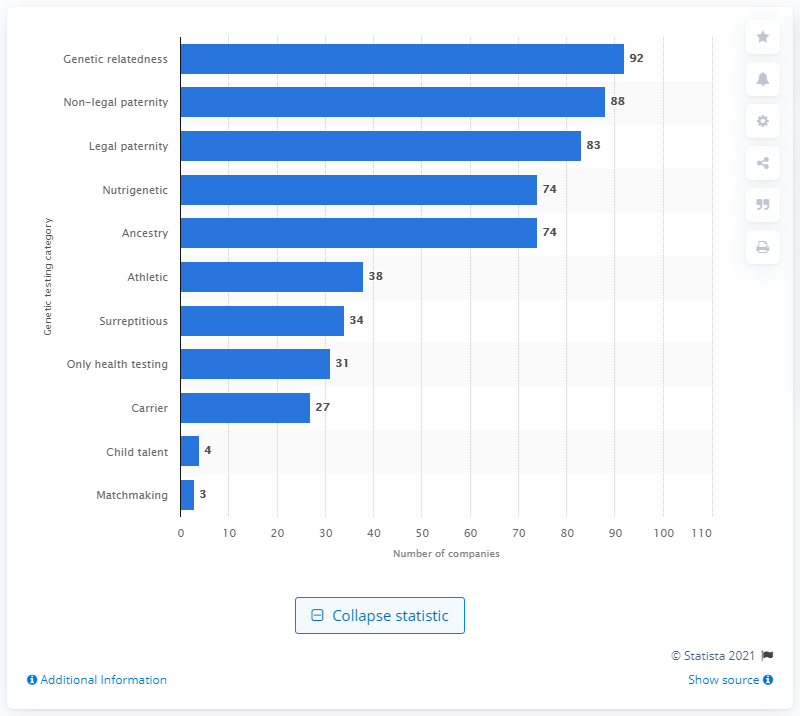List a handful of essential elements in this visual. In 2016, 74 companies offered DNA testing services to consumers. 